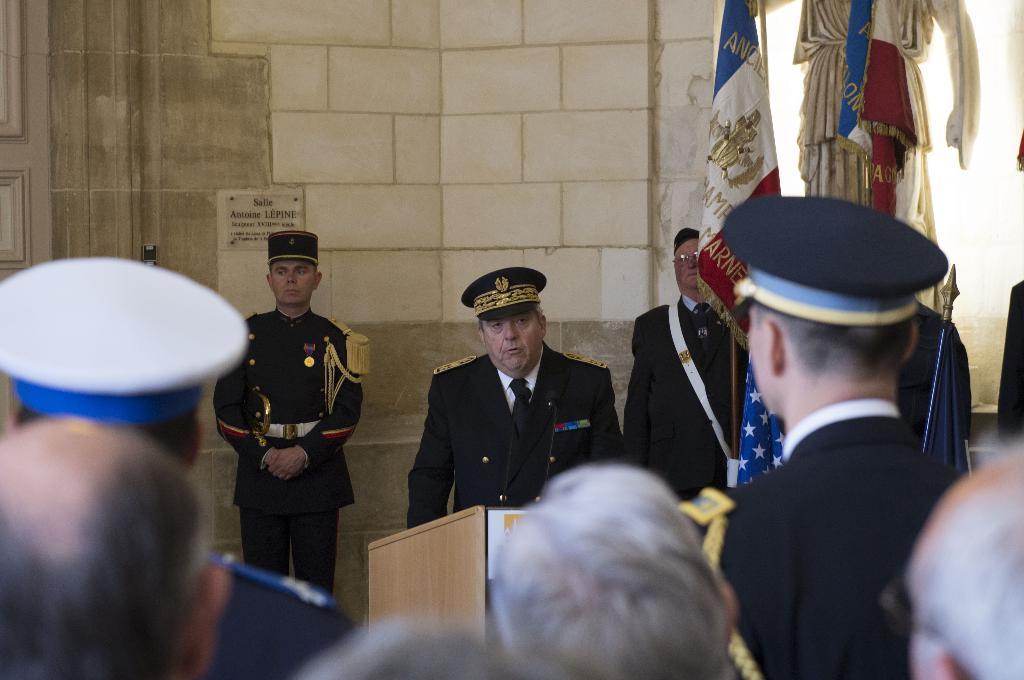How would you summarize this image in a sentence or two? In this image we can see people standing on the floor and one of them is standing at the podium to which mics are attached. In the background we can see flags to the flag posts and a name board to the wall. 